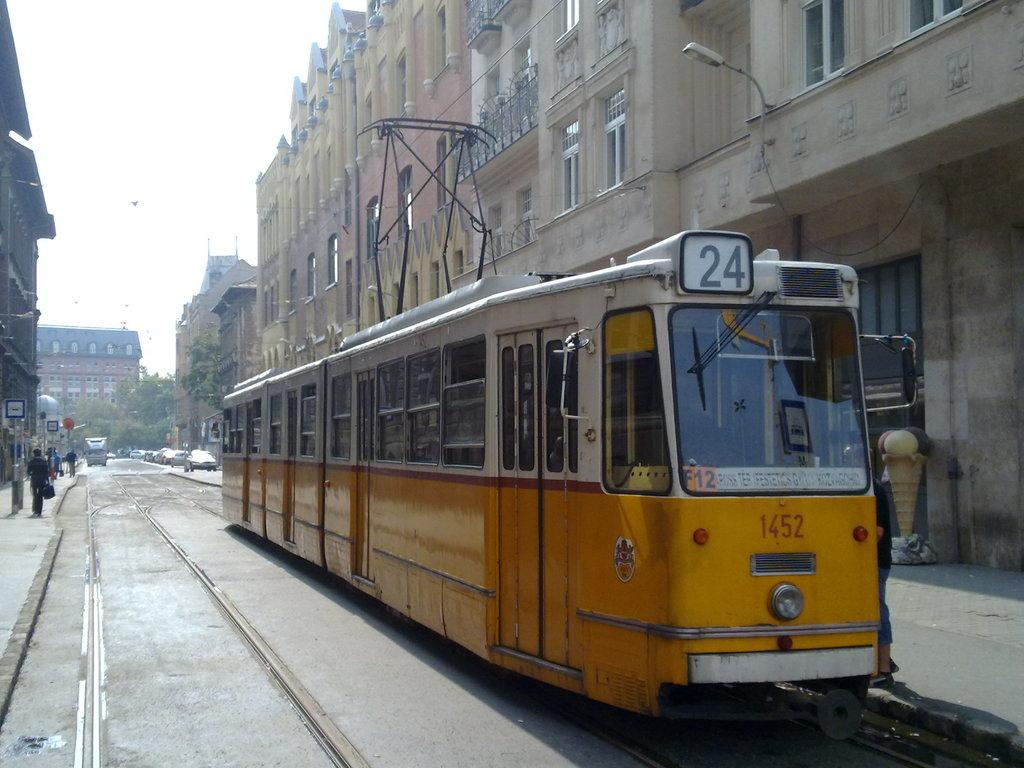<image>
Share a concise interpretation of the image provided. A yellow streetcar numbered 1452 with 24 on the top. 